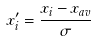Convert formula to latex. <formula><loc_0><loc_0><loc_500><loc_500>x _ { i } ^ { \prime } = \frac { { x _ { i } } - x _ { a v } } { \sigma }</formula> 